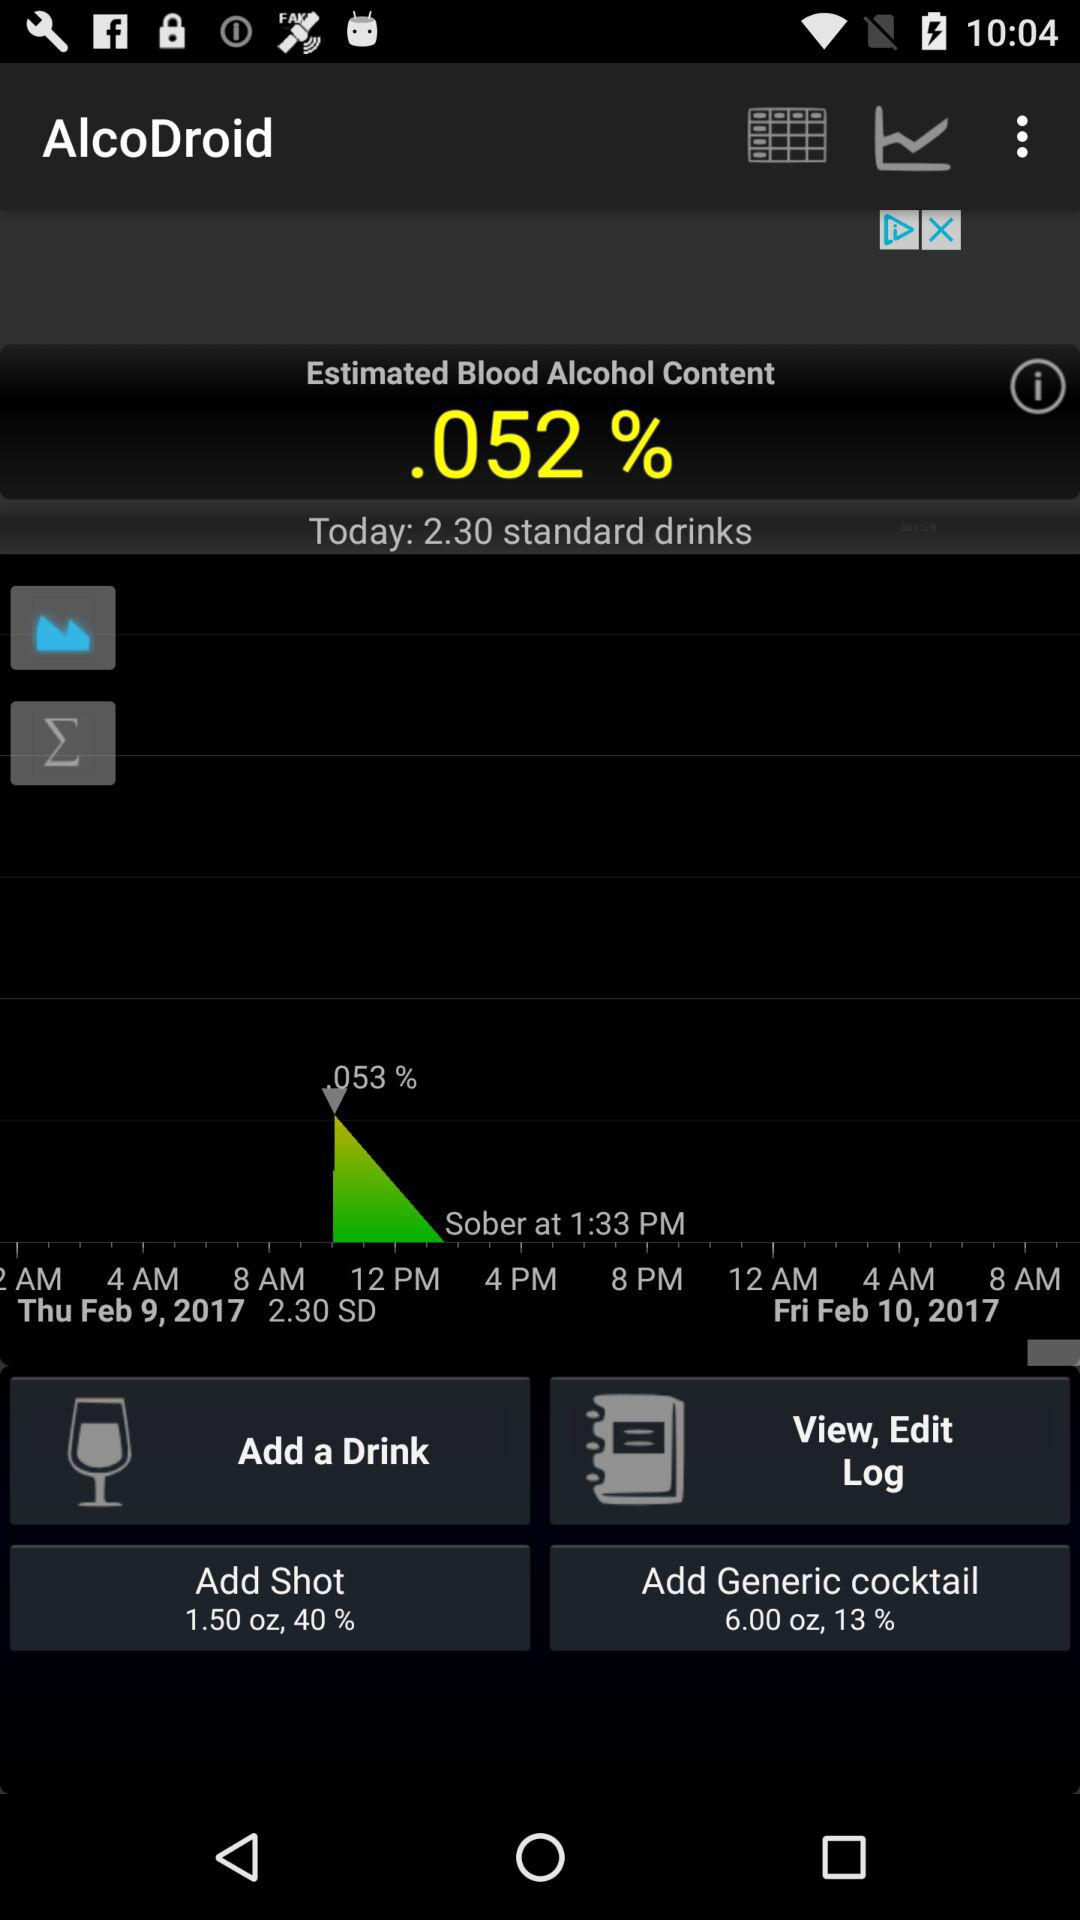What is the data in "Add Shot"? The data in "Add Shot" is 1.50 oz and 40%. 